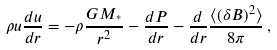<formula> <loc_0><loc_0><loc_500><loc_500>\rho u \frac { d u } { d r } = - \rho \frac { G M _ { ^ { * } } } { r ^ { 2 } } - \frac { d P } { d r } - \frac { d } { d r } \frac { \langle ( \delta B ) ^ { 2 } \rangle } { 8 \pi } \, ,</formula> 